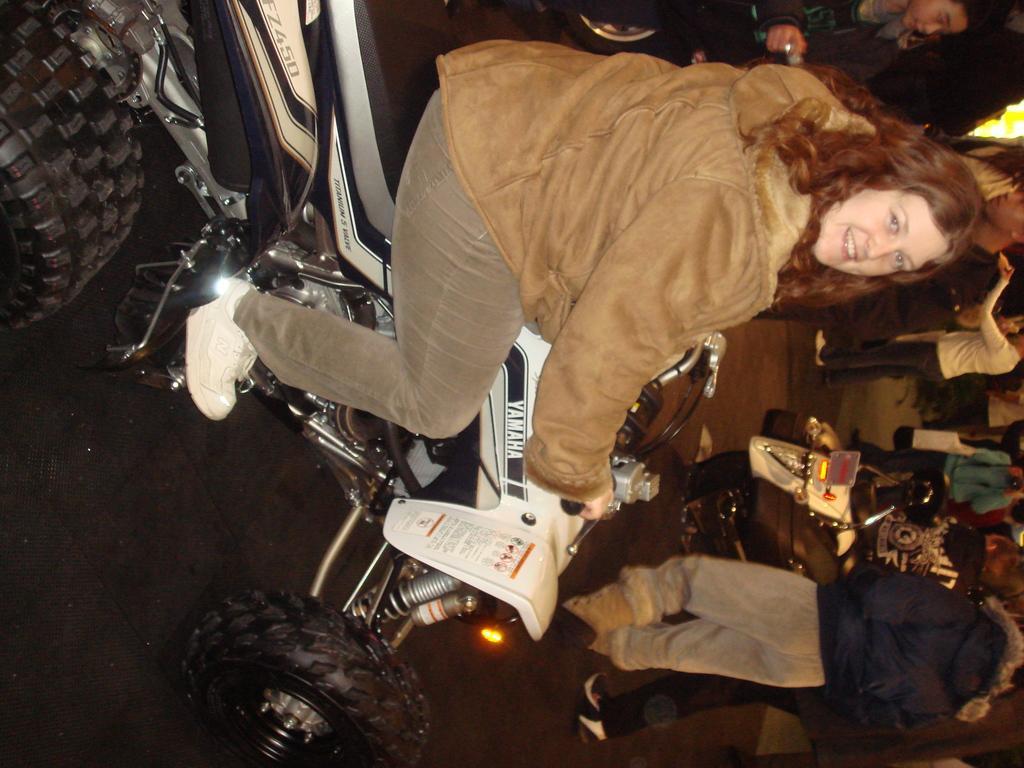Could you give a brief overview of what you see in this image? In this image, we can see a lady smiling and sitting on the bike. In the background, there are people and we can see another vehicle. 